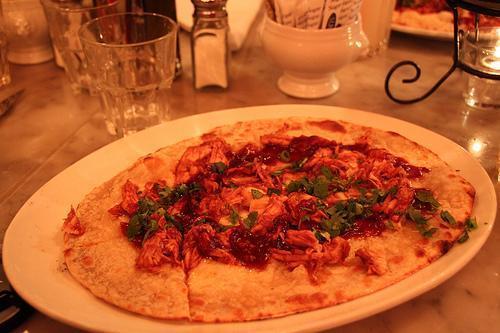How many salt shakers are on the table?
Give a very brief answer. 1. 